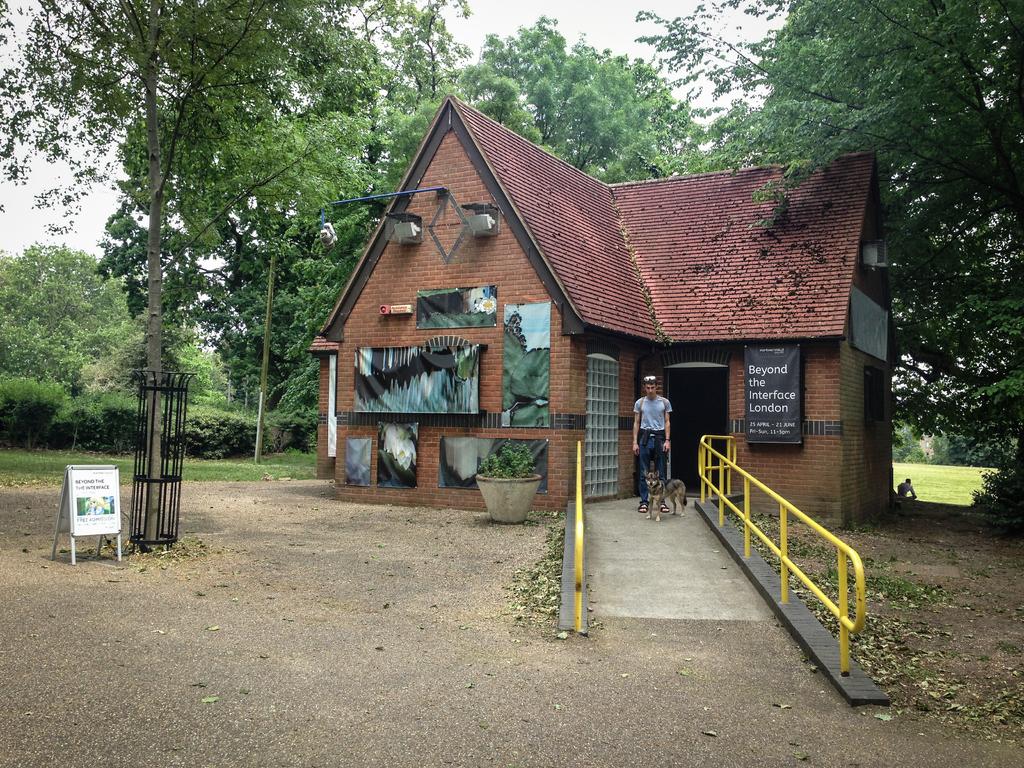Where is this photo taken?
Make the answer very short. London. What time is the event taking place?
Give a very brief answer. Unanswerable. 